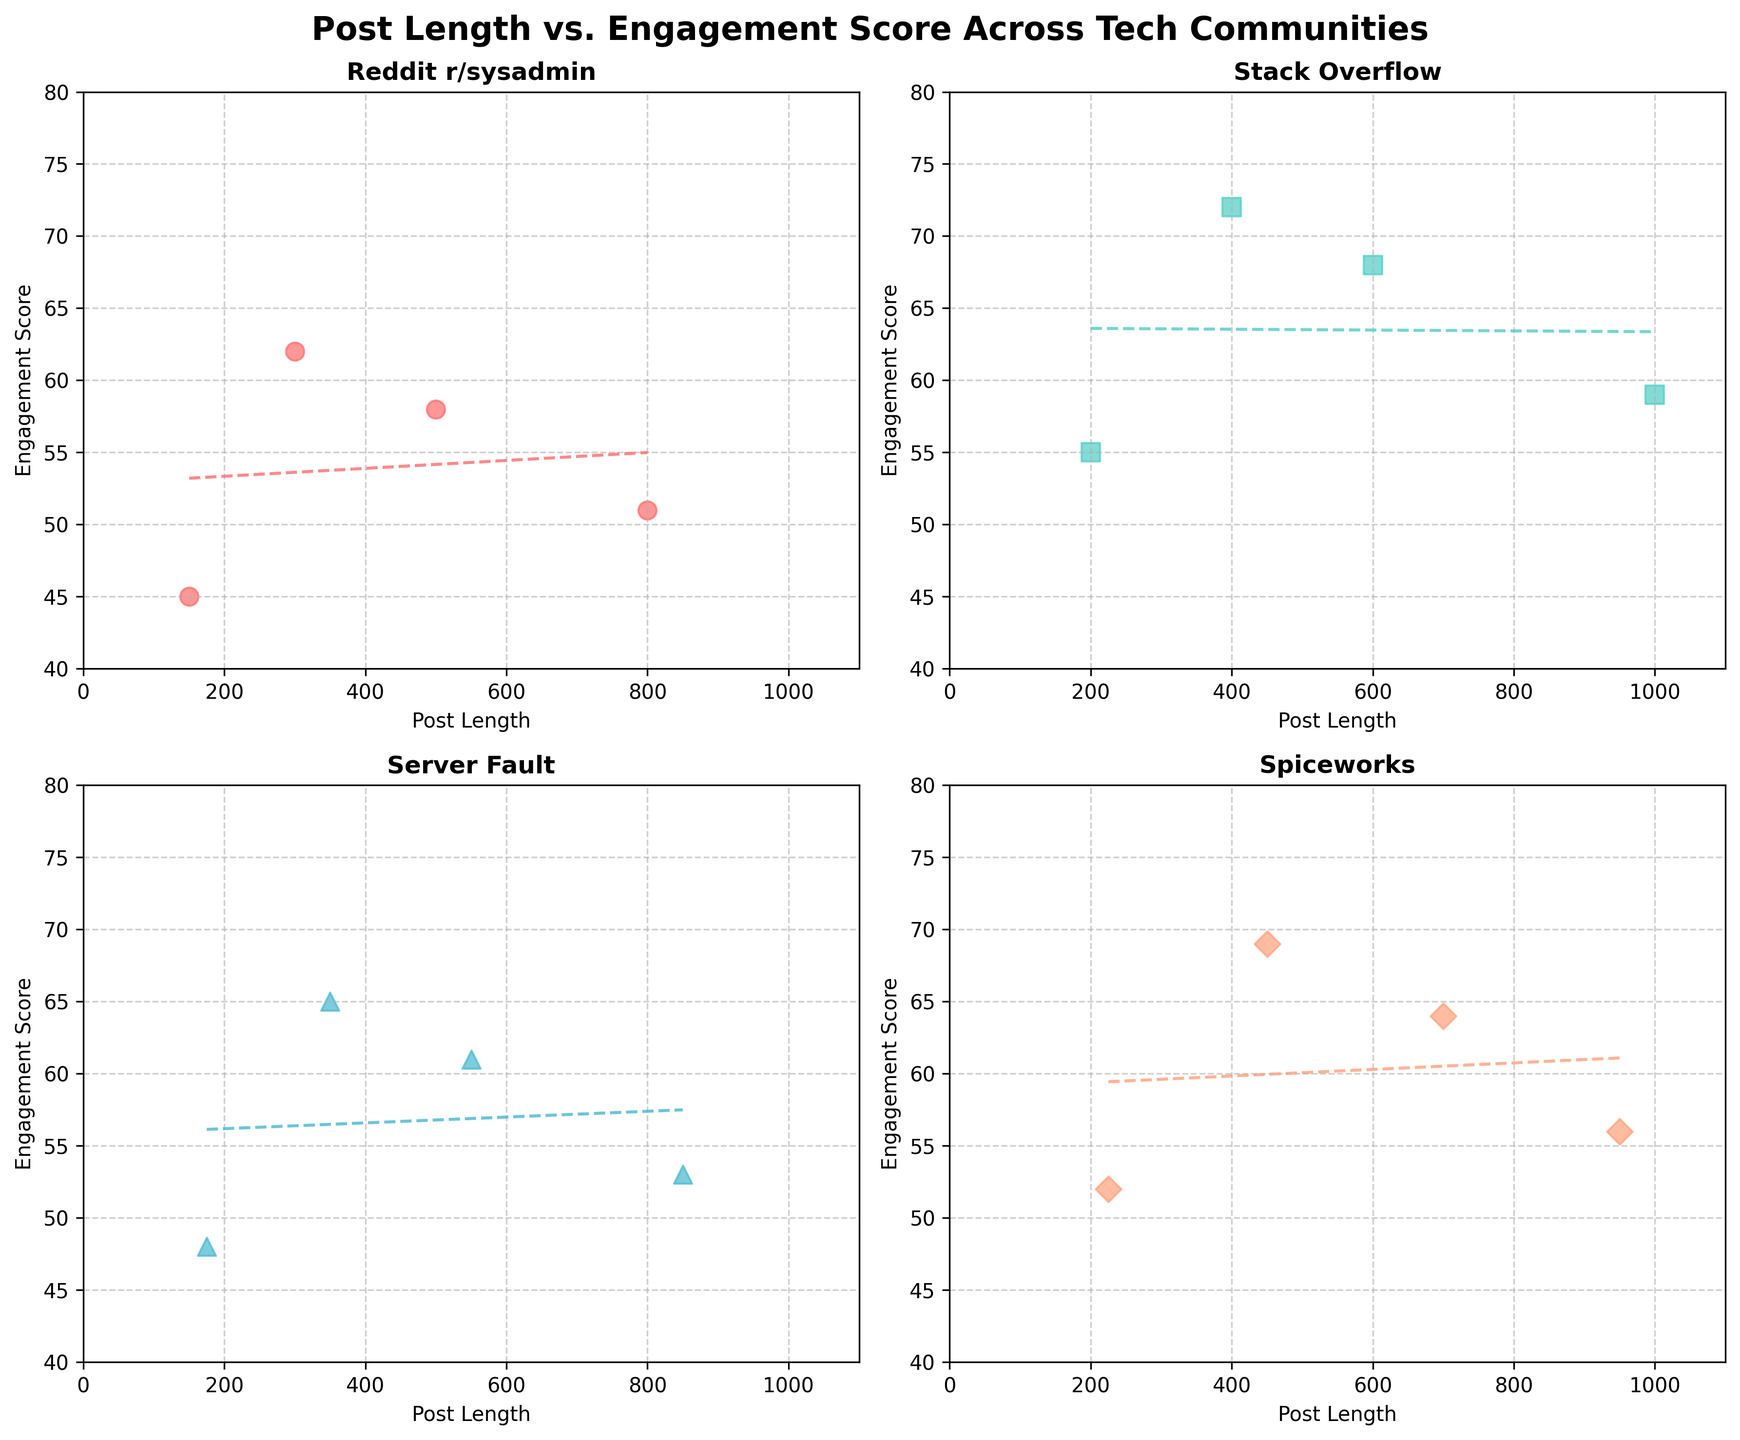What's the title of the figure? The title is written at the top of the figure, which is a general description of the entire plot. By reading the largest and bolded text, we can see it clearly.
Answer: Post Length vs. Engagement Score Across Tech Communities What are the communities represented in the figure? The subplot titles represent different communities, each of which is plotted separately. Reading the titles directly gives us the names of the communities.
Answer: Reddit r/sysadmin, Stack Overflow, Server Fault, Spiceworks What's the x-axis label in each subplot? The x-axis label is the same across all subplots, describing the horizontal axis. By looking at any of the subplots, we can quickly identify it.
Answer: Post Length Which community shows the highest engagement score for any post length? In order to find the maximum engagement score, we look for the highest data point in all subplots. This point is part of the Stack Overflow subplot, located around a post length of 400.
Answer: Stack Overflow How do trends differ between Reddit r/sysadmin and Server Fault? Comparing the trend lines in the Reddit r/sysadmin and Server Fault subplots, we see that the trend in Reddit r/sysadmin appears relatively flat, whereas Server Fault shows a slight decreasing trend.
Answer: Reddit r/sysadmin has a relatively flat trend; Server Fault shows a slight decreasing trend Which subplot has the most spread out engagement scores? To determine this, observe the range and distribution of the engagement scores points in each subplot. The Stack Overflow subplot shows the widest spread, with engagement scores ranging from around 55 to 72.
Answer: Stack Overflow What community has the highest average post length? First, visually judge the midpoint of the post lengths distribution for each community. Stack Overflow has more points concentrated at higher post lengths compared to other communities.
Answer: Stack Overflow What is the overall relationship between post length and engagement score in Spiceworks? By examining the trend line and the scatter points in the Spiceworks subplot, we can see a moderate downward trend, indicating a negative correlation.
Answer: Negative correlation Do any communities show a positive correlation between post length and engagement score? To find a positive correlation, check the trend lines' direction. The Stack Overflow subplot shows a positive trend line as the post length increases.
Answer: Stack Overflow Which community has the steepest decline in engagement score as post length increases? The steepness of trend lines indicates the rate of decline. The Spiceworks subplot has the steepest negatively-sloped trend line.
Answer: Spiceworks 